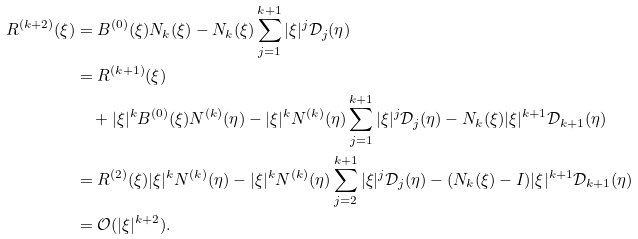Convert formula to latex. <formula><loc_0><loc_0><loc_500><loc_500>R ^ { ( k + 2 ) } ( \xi ) & = B ^ { ( 0 ) } ( \xi ) N _ { k } ( \xi ) - N _ { k } ( \xi ) \sum _ { j = 1 } ^ { k + 1 } | \xi | ^ { j } \mathcal { D } _ { j } ( \eta ) \\ & = R ^ { ( k + 1 ) } ( \xi ) \\ & \quad + | \xi | ^ { k } B ^ { ( 0 ) } ( \xi ) N ^ { ( k ) } ( \eta ) - | \xi | ^ { k } N ^ { ( k ) } ( \eta ) \sum _ { j = 1 } ^ { k + 1 } | \xi | ^ { j } \mathcal { D } _ { j } ( \eta ) - N _ { k } ( \xi ) | \xi | ^ { k + 1 } \mathcal { D } _ { k + 1 } ( \eta ) \\ & = R ^ { ( 2 ) } ( \xi ) | \xi | ^ { k } N ^ { ( k ) } ( \eta ) - | \xi | ^ { k } N ^ { ( k ) } ( \eta ) \sum _ { j = 2 } ^ { k + 1 } | \xi | ^ { j } \mathcal { D } _ { j } ( \eta ) - ( N _ { k } ( \xi ) - I ) | \xi | ^ { k + 1 } \mathcal { D } _ { k + 1 } ( \eta ) \\ & = \mathcal { O } ( | \xi | ^ { k + 2 } ) .</formula> 